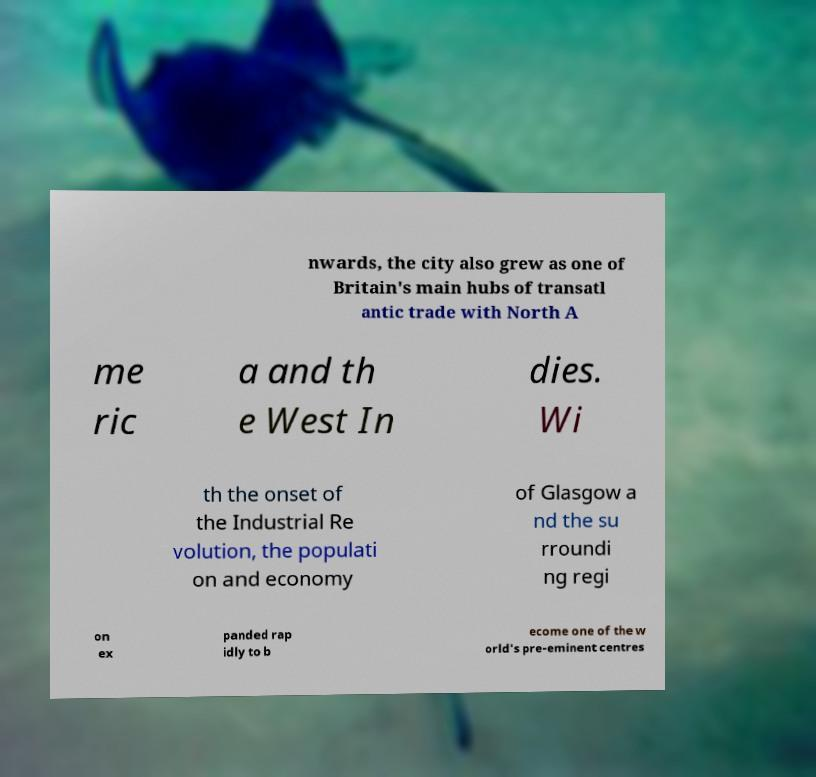Can you read and provide the text displayed in the image?This photo seems to have some interesting text. Can you extract and type it out for me? nwards, the city also grew as one of Britain's main hubs of transatl antic trade with North A me ric a and th e West In dies. Wi th the onset of the Industrial Re volution, the populati on and economy of Glasgow a nd the su rroundi ng regi on ex panded rap idly to b ecome one of the w orld's pre-eminent centres 